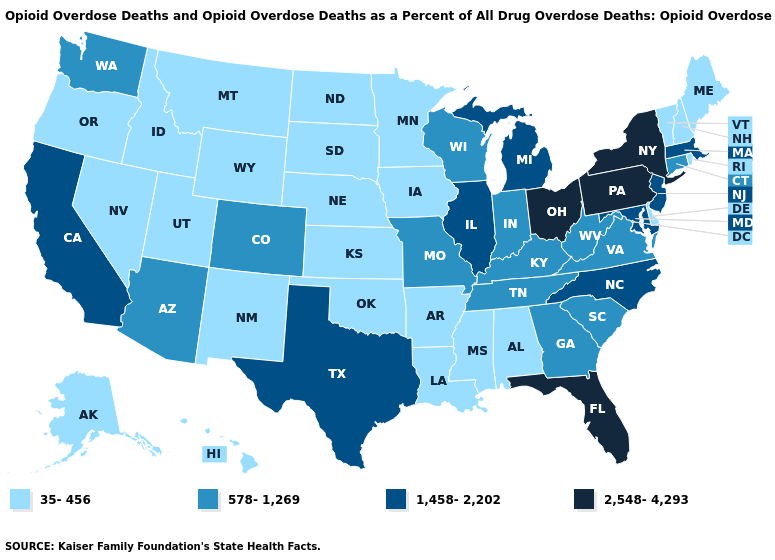Does Arkansas have a lower value than Wyoming?
Write a very short answer. No. Does Michigan have the lowest value in the MidWest?
Give a very brief answer. No. What is the value of Texas?
Short answer required. 1,458-2,202. What is the highest value in the USA?
Short answer required. 2,548-4,293. Does the first symbol in the legend represent the smallest category?
Write a very short answer. Yes. Name the states that have a value in the range 578-1,269?
Short answer required. Arizona, Colorado, Connecticut, Georgia, Indiana, Kentucky, Missouri, South Carolina, Tennessee, Virginia, Washington, West Virginia, Wisconsin. What is the highest value in the MidWest ?
Answer briefly. 2,548-4,293. Name the states that have a value in the range 2,548-4,293?
Short answer required. Florida, New York, Ohio, Pennsylvania. Does Michigan have a higher value than Massachusetts?
Quick response, please. No. Does Alabama have the lowest value in the South?
Keep it brief. Yes. Which states have the lowest value in the USA?
Concise answer only. Alabama, Alaska, Arkansas, Delaware, Hawaii, Idaho, Iowa, Kansas, Louisiana, Maine, Minnesota, Mississippi, Montana, Nebraska, Nevada, New Hampshire, New Mexico, North Dakota, Oklahoma, Oregon, Rhode Island, South Dakota, Utah, Vermont, Wyoming. What is the highest value in states that border Texas?
Concise answer only. 35-456. Does Oregon have a lower value than Michigan?
Keep it brief. Yes. 